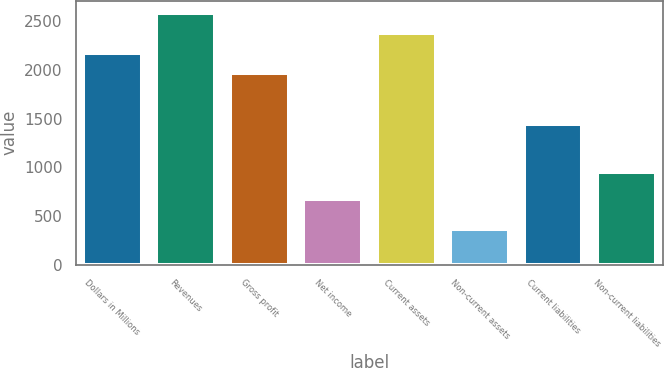Convert chart to OTSL. <chart><loc_0><loc_0><loc_500><loc_500><bar_chart><fcel>Dollars in Millions<fcel>Revenues<fcel>Gross profit<fcel>Net income<fcel>Current assets<fcel>Non-current assets<fcel>Current liabilities<fcel>Non-current liabilities<nl><fcel>2170.6<fcel>2581.8<fcel>1965<fcel>673<fcel>2376.2<fcel>371<fcel>1447<fcel>949<nl></chart> 